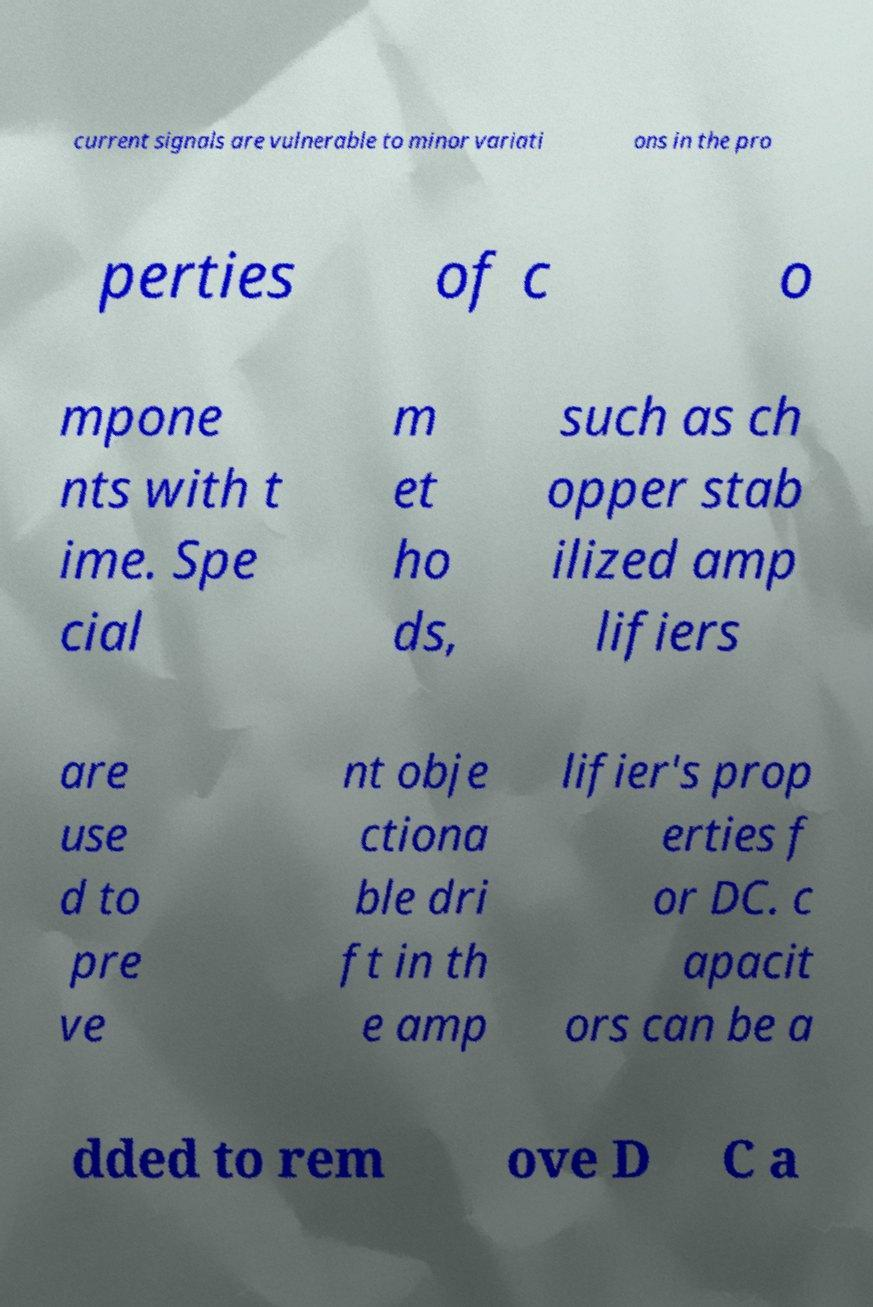Can you read and provide the text displayed in the image?This photo seems to have some interesting text. Can you extract and type it out for me? current signals are vulnerable to minor variati ons in the pro perties of c o mpone nts with t ime. Spe cial m et ho ds, such as ch opper stab ilized amp lifiers are use d to pre ve nt obje ctiona ble dri ft in th e amp lifier's prop erties f or DC. c apacit ors can be a dded to rem ove D C a 